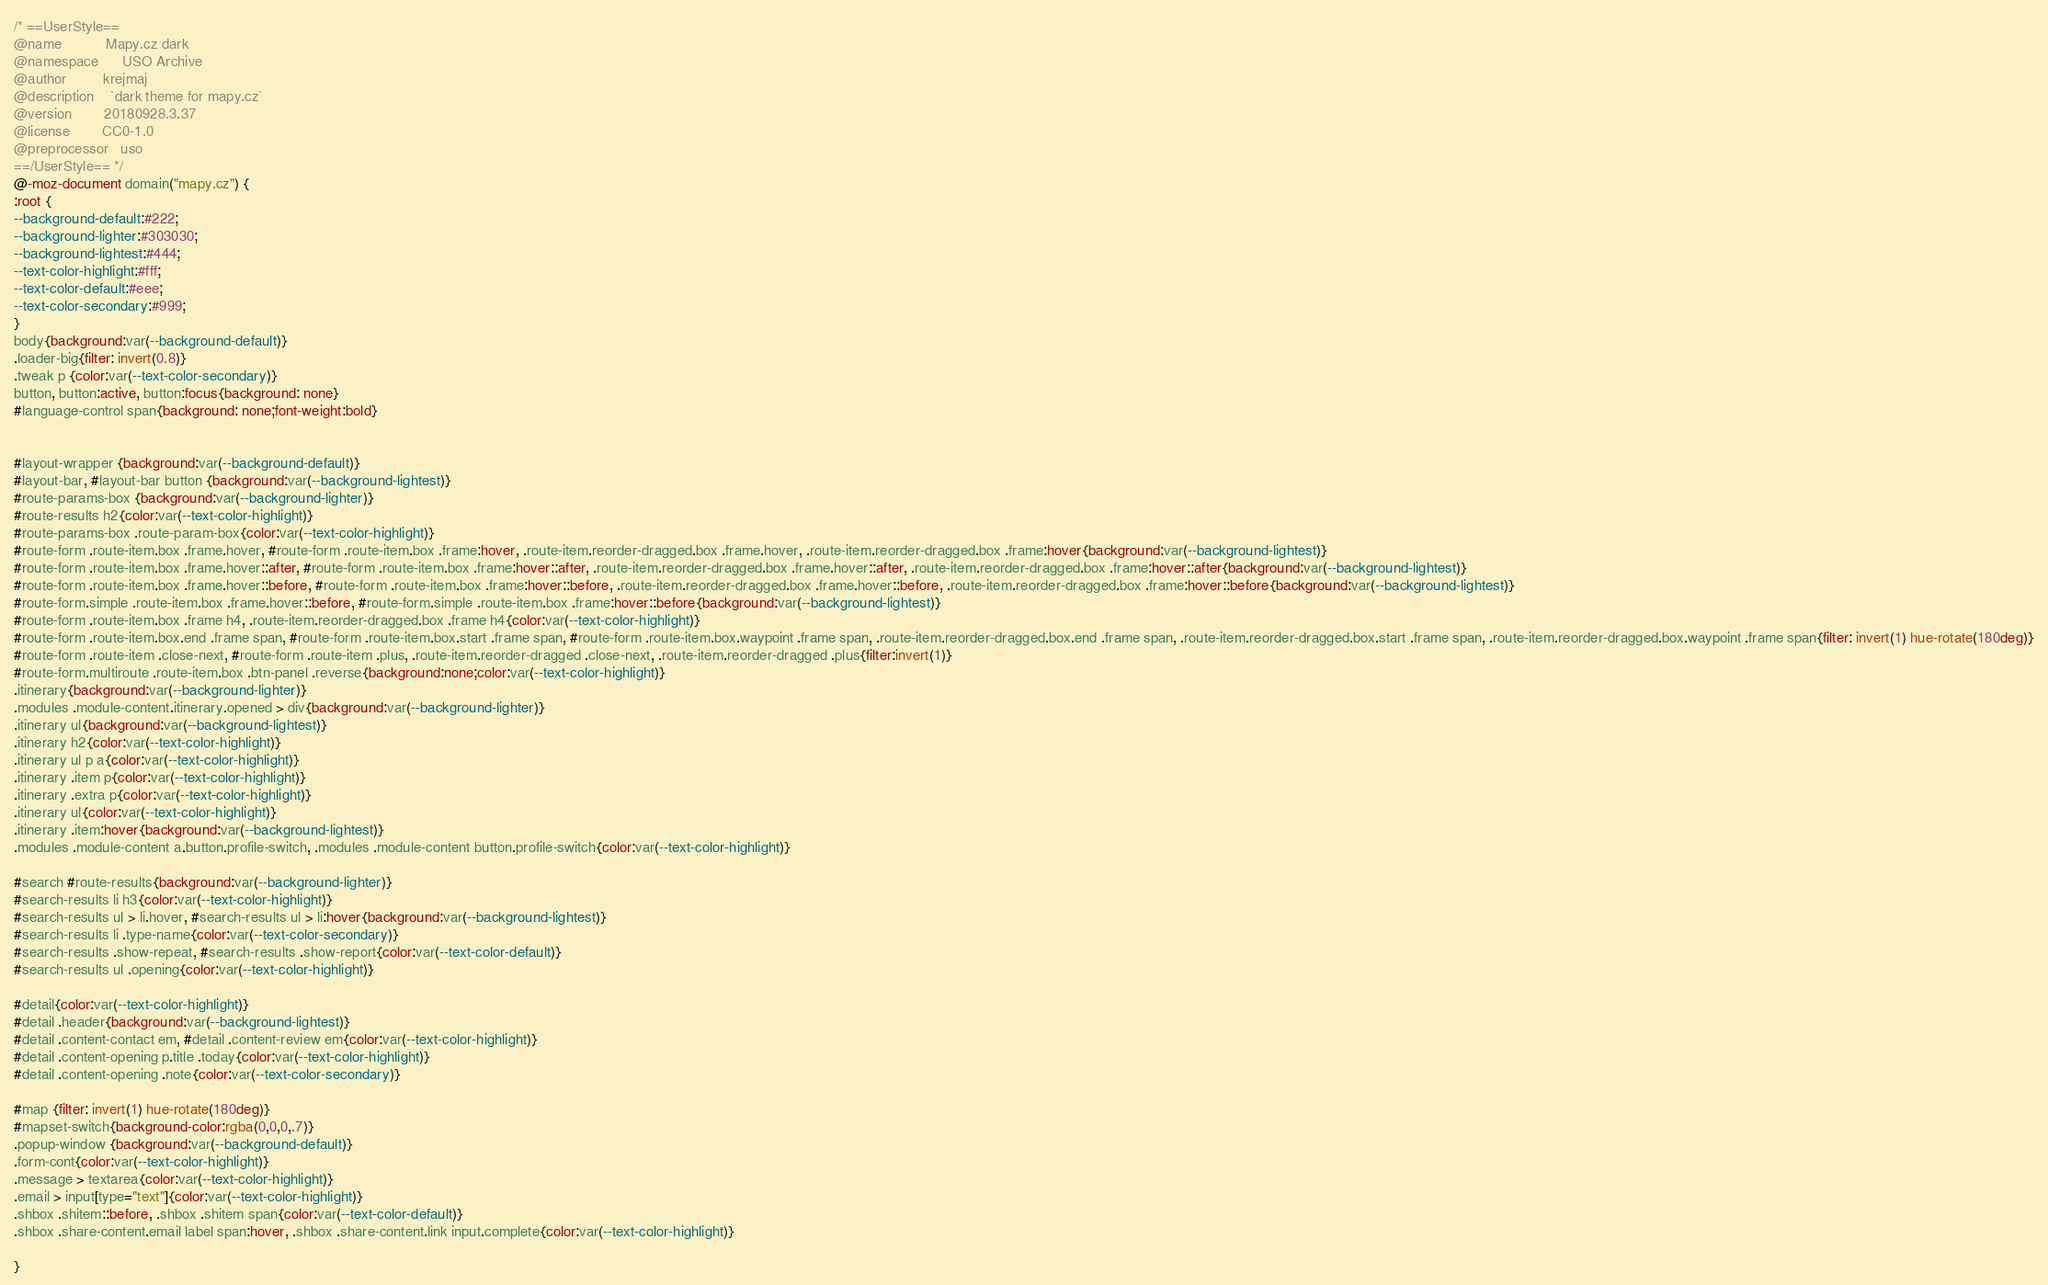Convert code to text. <code><loc_0><loc_0><loc_500><loc_500><_CSS_>/* ==UserStyle==
@name           Mapy.cz dark
@namespace      USO Archive
@author         krejmaj
@description    `dark theme for mapy.cz`
@version        20180928.3.37
@license        CC0-1.0
@preprocessor   uso
==/UserStyle== */
@-moz-document domain("mapy.cz") {
:root {
--background-default:#222;
--background-lighter:#303030;
--background-lightest:#444;
--text-color-highlight:#fff;
--text-color-default:#eee;
--text-color-secondary:#999;
}
body{background:var(--background-default)}
.loader-big{filter: invert(0.8)}
.tweak p {color:var(--text-color-secondary)}
button, button:active, button:focus{background: none}
#language-control span{background: none;font-weight:bold}


#layout-wrapper {background:var(--background-default)}
#layout-bar, #layout-bar button {background:var(--background-lightest)}
#route-params-box {background:var(--background-lighter)}
#route-results h2{color:var(--text-color-highlight)}
#route-params-box .route-param-box{color:var(--text-color-highlight)}
#route-form .route-item.box .frame.hover, #route-form .route-item.box .frame:hover, .route-item.reorder-dragged.box .frame.hover, .route-item.reorder-dragged.box .frame:hover{background:var(--background-lightest)}
#route-form .route-item.box .frame.hover::after, #route-form .route-item.box .frame:hover::after, .route-item.reorder-dragged.box .frame.hover::after, .route-item.reorder-dragged.box .frame:hover::after{background:var(--background-lightest)}
#route-form .route-item.box .frame.hover::before, #route-form .route-item.box .frame:hover::before, .route-item.reorder-dragged.box .frame.hover::before, .route-item.reorder-dragged.box .frame:hover::before{background:var(--background-lightest)}
#route-form.simple .route-item.box .frame.hover::before, #route-form.simple .route-item.box .frame:hover::before{background:var(--background-lightest)}
#route-form .route-item.box .frame h4, .route-item.reorder-dragged.box .frame h4{color:var(--text-color-highlight)}
#route-form .route-item.box.end .frame span, #route-form .route-item.box.start .frame span, #route-form .route-item.box.waypoint .frame span, .route-item.reorder-dragged.box.end .frame span, .route-item.reorder-dragged.box.start .frame span, .route-item.reorder-dragged.box.waypoint .frame span{filter: invert(1) hue-rotate(180deg)}
#route-form .route-item .close-next, #route-form .route-item .plus, .route-item.reorder-dragged .close-next, .route-item.reorder-dragged .plus{filter:invert(1)}
#route-form.multiroute .route-item.box .btn-panel .reverse{background:none;color:var(--text-color-highlight)}
.itinerary{background:var(--background-lighter)}
.modules .module-content.itinerary.opened > div{background:var(--background-lighter)}
.itinerary ul{background:var(--background-lightest)}
.itinerary h2{color:var(--text-color-highlight)}
.itinerary ul p a{color:var(--text-color-highlight)}
.itinerary .item p{color:var(--text-color-highlight)}
.itinerary .extra p{color:var(--text-color-highlight)}
.itinerary ul{color:var(--text-color-highlight)}
.itinerary .item:hover{background:var(--background-lightest)}
.modules .module-content a.button.profile-switch, .modules .module-content button.profile-switch{color:var(--text-color-highlight)}

#search #route-results{background:var(--background-lighter)}
#search-results li h3{color:var(--text-color-highlight)}
#search-results ul > li.hover, #search-results ul > li:hover{background:var(--background-lightest)}
#search-results li .type-name{color:var(--text-color-secondary)}
#search-results .show-repeat, #search-results .show-report{color:var(--text-color-default)}
#search-results ul .opening{color:var(--text-color-highlight)}

#detail{color:var(--text-color-highlight)}
#detail .header{background:var(--background-lightest)}
#detail .content-contact em, #detail .content-review em{color:var(--text-color-highlight)}
#detail .content-opening p.title .today{color:var(--text-color-highlight)}
#detail .content-opening .note{color:var(--text-color-secondary)}

#map {filter: invert(1) hue-rotate(180deg)}
#mapset-switch{background-color:rgba(0,0,0,.7)}
.popup-window {background:var(--background-default)}
.form-cont{color:var(--text-color-highlight)}
.message > textarea{color:var(--text-color-highlight)}
.email > input[type="text"]{color:var(--text-color-highlight)}
.shbox .shitem::before, .shbox .shitem span{color:var(--text-color-default)}
.shbox .share-content.email label span:hover, .shbox .share-content.link input.complete{color:var(--text-color-highlight)}

}</code> 